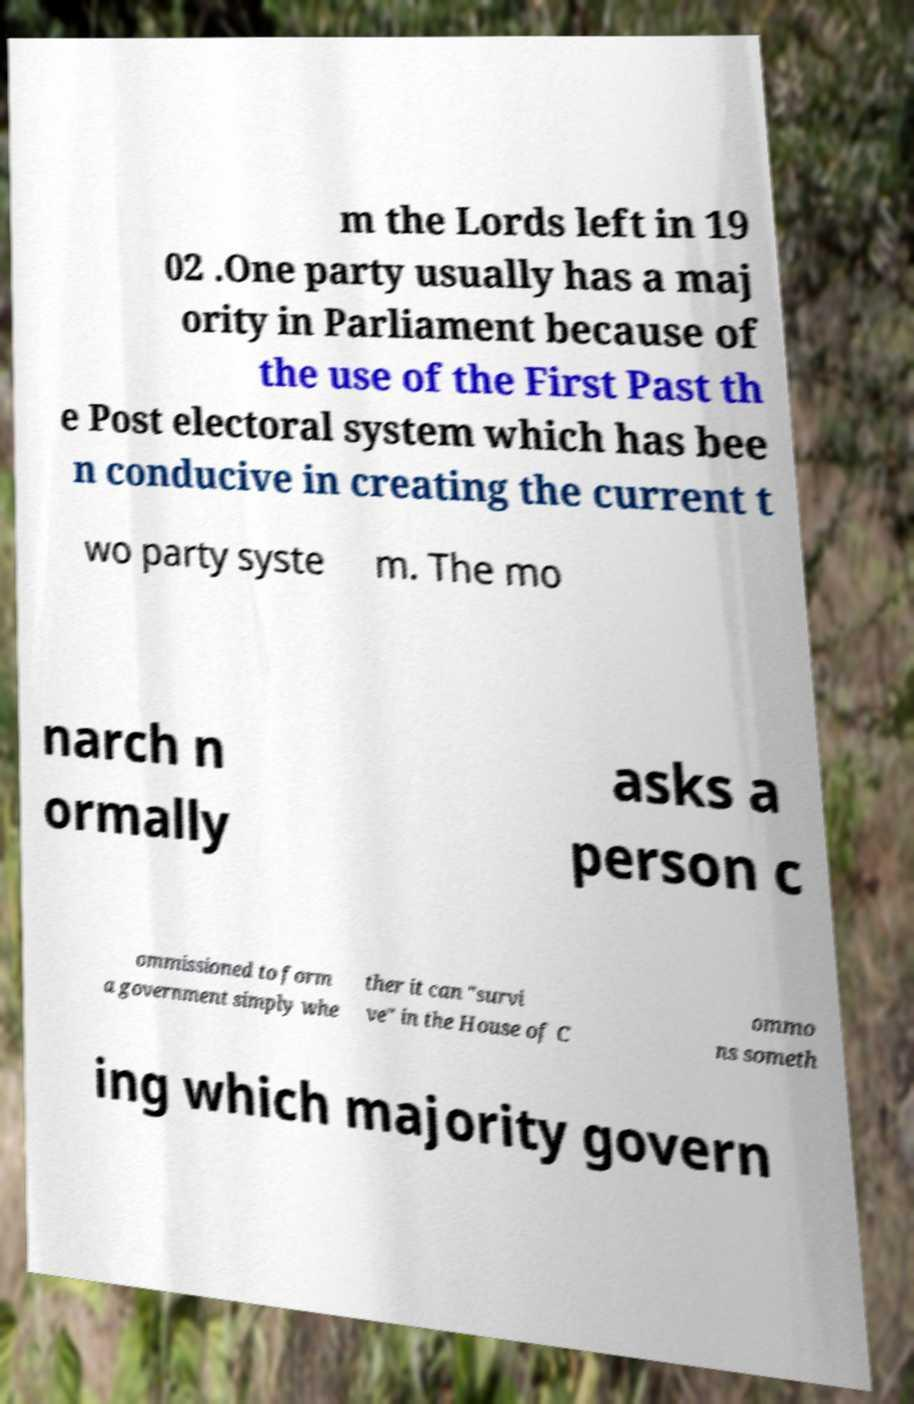There's text embedded in this image that I need extracted. Can you transcribe it verbatim? m the Lords left in 19 02 .One party usually has a maj ority in Parliament because of the use of the First Past th e Post electoral system which has bee n conducive in creating the current t wo party syste m. The mo narch n ormally asks a person c ommissioned to form a government simply whe ther it can "survi ve" in the House of C ommo ns someth ing which majority govern 